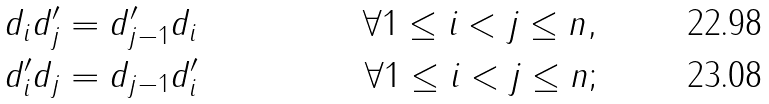<formula> <loc_0><loc_0><loc_500><loc_500>d _ { i } d ^ { \prime } _ { j } & = d ^ { \prime } _ { j - 1 } d _ { i } & \forall 1 \leq i < j \leq n , \\ d ^ { \prime } _ { i } d _ { j } & = d _ { j - 1 } d ^ { \prime } _ { i } & \forall 1 \leq i < j \leq n ;</formula> 